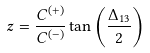<formula> <loc_0><loc_0><loc_500><loc_500>z = \frac { C ^ { ( + ) } } { C ^ { ( - ) } } \tan { \left ( \frac { \Delta _ { 1 3 } } { 2 } \right ) }</formula> 